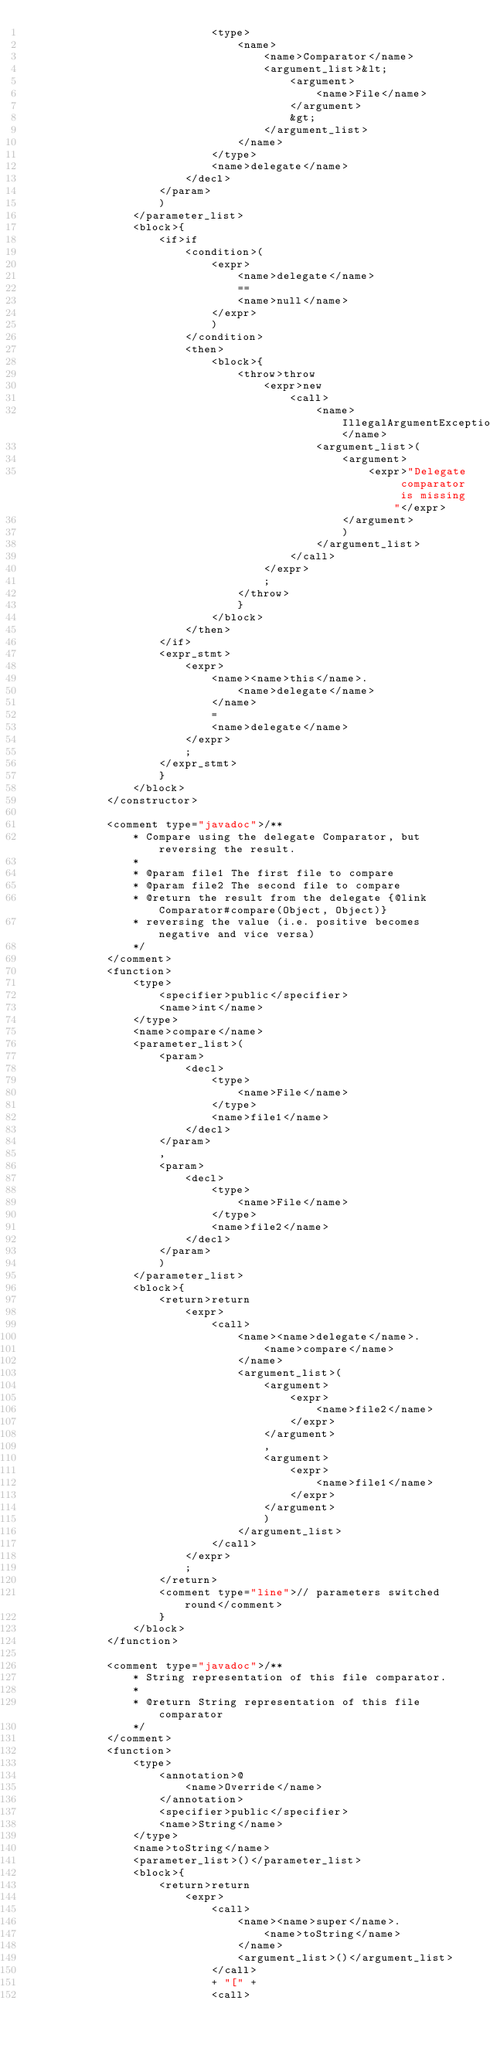Convert code to text. <code><loc_0><loc_0><loc_500><loc_500><_XML_>                            <type>
                                <name>
                                    <name>Comparator</name>
                                    <argument_list>&lt;
                                        <argument>
                                            <name>File</name>
                                        </argument>
                                        &gt;
                                    </argument_list>
                                </name>
                            </type>
                            <name>delegate</name>
                        </decl>
                    </param>
                    )
                </parameter_list>
                <block>{
                    <if>if
                        <condition>(
                            <expr>
                                <name>delegate</name>
                                ==
                                <name>null</name>
                            </expr>
                            )
                        </condition>
                        <then>
                            <block>{
                                <throw>throw
                                    <expr>new
                                        <call>
                                            <name>IllegalArgumentException</name>
                                            <argument_list>(
                                                <argument>
                                                    <expr>"Delegate comparator is missing"</expr>
                                                </argument>
                                                )
                                            </argument_list>
                                        </call>
                                    </expr>
                                    ;
                                </throw>
                                }
                            </block>
                        </then>
                    </if>
                    <expr_stmt>
                        <expr>
                            <name><name>this</name>.
                                <name>delegate</name>
                            </name>
                            =
                            <name>delegate</name>
                        </expr>
                        ;
                    </expr_stmt>
                    }
                </block>
            </constructor>

            <comment type="javadoc">/**
                * Compare using the delegate Comparator, but reversing the result.
                *
                * @param file1 The first file to compare
                * @param file2 The second file to compare
                * @return the result from the delegate {@link Comparator#compare(Object, Object)}
                * reversing the value (i.e. positive becomes negative and vice versa)
                */
            </comment>
            <function>
                <type>
                    <specifier>public</specifier>
                    <name>int</name>
                </type>
                <name>compare</name>
                <parameter_list>(
                    <param>
                        <decl>
                            <type>
                                <name>File</name>
                            </type>
                            <name>file1</name>
                        </decl>
                    </param>
                    ,
                    <param>
                        <decl>
                            <type>
                                <name>File</name>
                            </type>
                            <name>file2</name>
                        </decl>
                    </param>
                    )
                </parameter_list>
                <block>{
                    <return>return
                        <expr>
                            <call>
                                <name><name>delegate</name>.
                                    <name>compare</name>
                                </name>
                                <argument_list>(
                                    <argument>
                                        <expr>
                                            <name>file2</name>
                                        </expr>
                                    </argument>
                                    ,
                                    <argument>
                                        <expr>
                                            <name>file1</name>
                                        </expr>
                                    </argument>
                                    )
                                </argument_list>
                            </call>
                        </expr>
                        ;
                    </return>
                    <comment type="line">// parameters switched round</comment>
                    }
                </block>
            </function>

            <comment type="javadoc">/**
                * String representation of this file comparator.
                *
                * @return String representation of this file comparator
                */
            </comment>
            <function>
                <type>
                    <annotation>@
                        <name>Override</name>
                    </annotation>
                    <specifier>public</specifier>
                    <name>String</name>
                </type>
                <name>toString</name>
                <parameter_list>()</parameter_list>
                <block>{
                    <return>return
                        <expr>
                            <call>
                                <name><name>super</name>.
                                    <name>toString</name>
                                </name>
                                <argument_list>()</argument_list>
                            </call>
                            + "[" +
                            <call></code> 